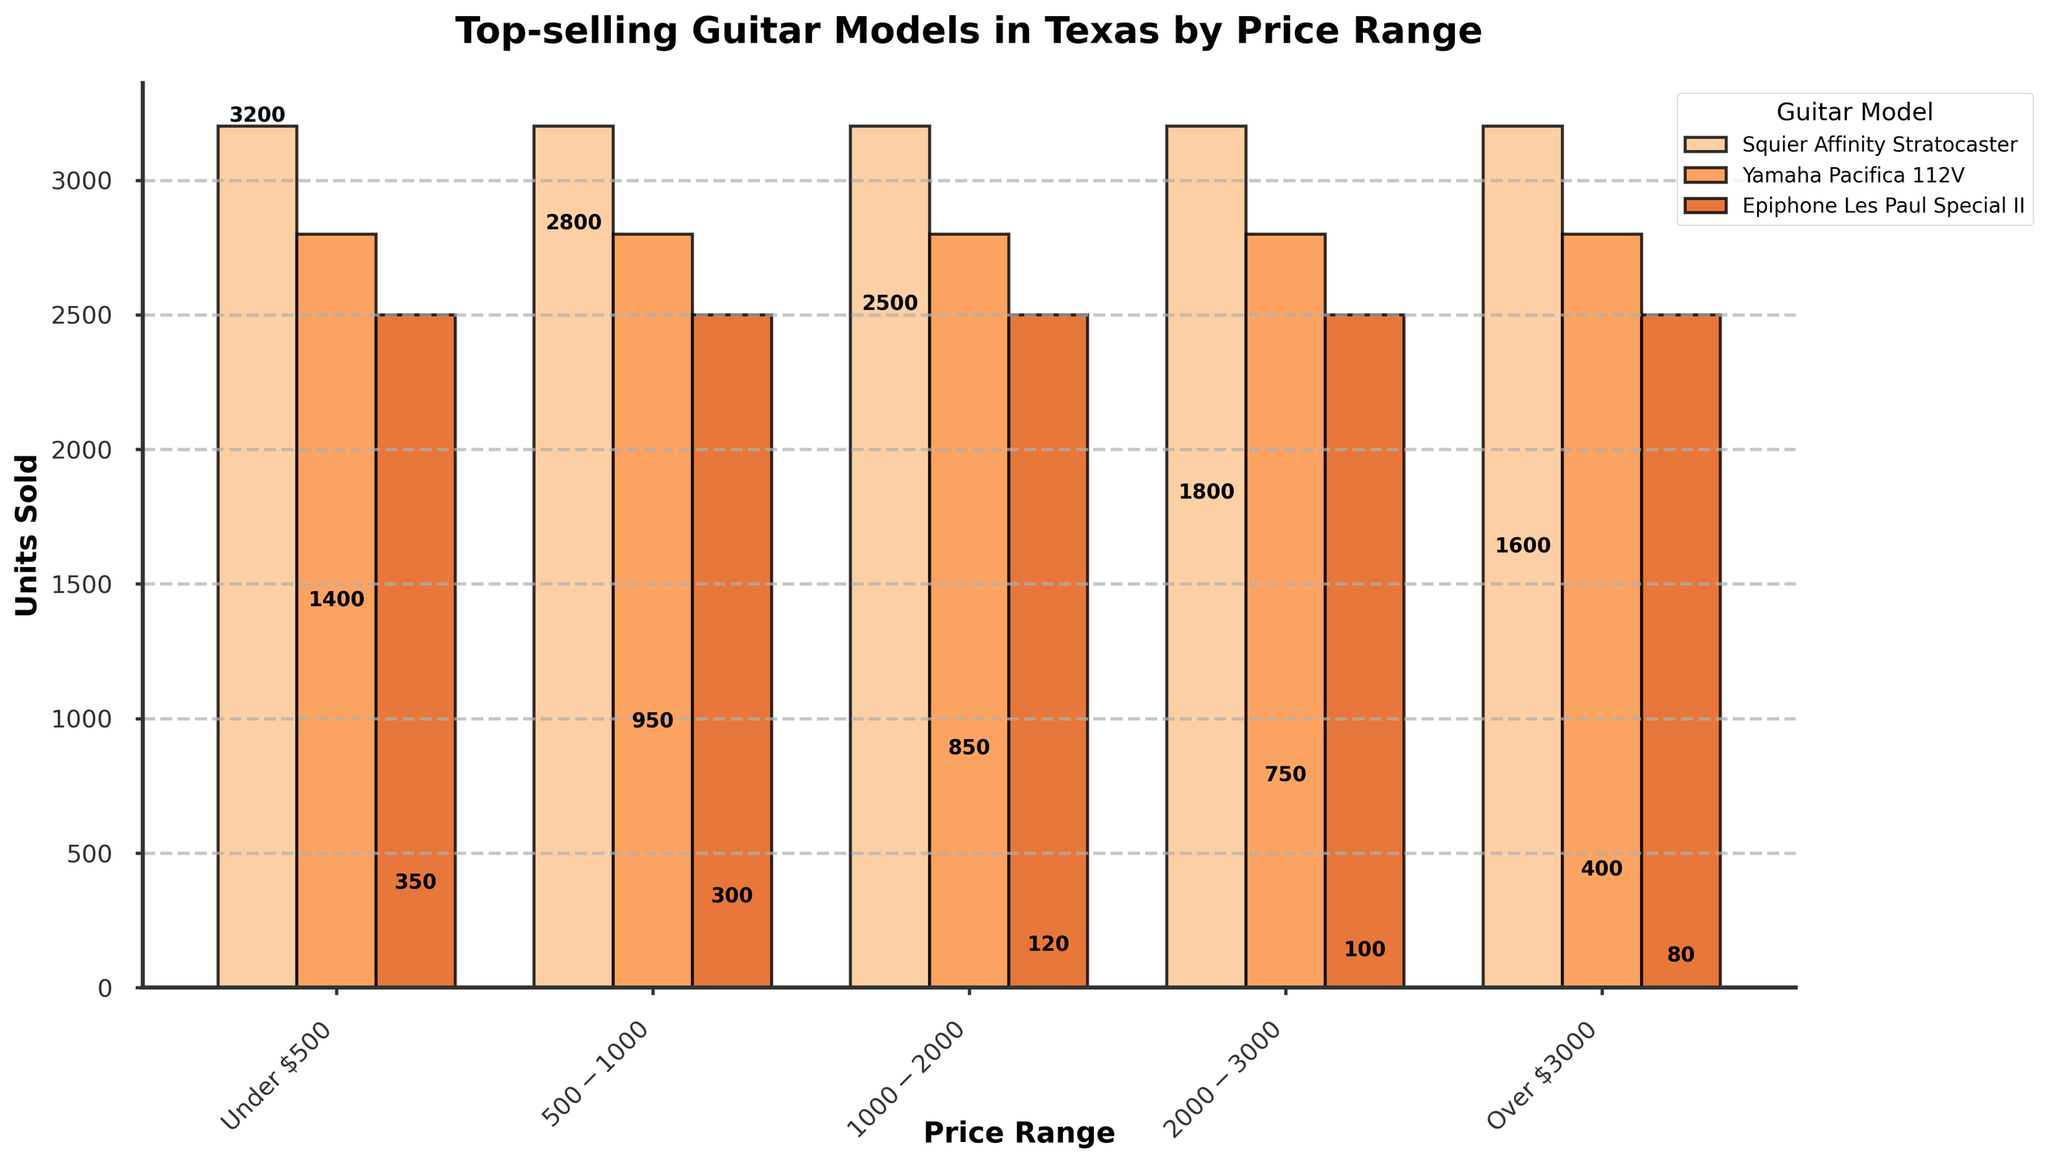What is the total number of units sold for guitar models in the price range Under $500? Add the units sold for Squier Affinity Stratocaster (3200), Yamaha Pacifica 112V (2800), and Epiphone Les Paul Special II (2500). 3200 + 2800 + 2500 = 8500.
Answer: 8500 Which guitar model in the $2000-$3000 price range sold the least number of units? Compare the units sold for Martin D-28 (400), Fender American Professional II Stratocaster (350), and Gibson SG Standard '61 (300). The Gibson SG Standard '61 has the least units sold.
Answer: Gibson SG Standard '61 Between the $500-$1000 and $1000-$2000 price ranges, which one has the higher total units sold? Sum the units sold for the $500-$1000 range (1800 + 1600 + 1400 = 4800) and the $1000-$2000 range (950 + 850 + 750 = 2550). Compare the totals: 4800 > 2550.
Answer: $500-$1000 What is the difference in units sold between the highest-selling guitar model and the lowest-selling guitar model? The highest-selling model is Squier Affinity Stratocaster (3200) and the lowest-selling model is Paul Reed Smith Custom 24 (80). Calculate 3200 - 80 = 3120.
Answer: 3120 Which guitar model among the Over $3000 price range has the second-highest units sold? Compare the units sold for Gibson Custom Shop 1959 Les Paul Standard Reissue (120), Fender Custom Shop 1960 Stratocaster Relic (100), and Paul Reed Smith Custom 24 (80). The second-highest is Fender Custom Shop 1960 Stratocaster Relic with 100 units.
Answer: Fender Custom Shop 1960 Stratocaster Relic How many more units did the Martin D-28 sell compared to the Fender American Professional II Stratocaster? The units sold for Martin D-28 is 400 and for Fender American Professional II Stratocaster is 350. Calculate 400 - 350 = 50.
Answer: 50 Which price range shows the greatest variability in units sold among its models? Assess visually by comparing the highest and lowest units sold within each price range. The $500-$1000 range (1800 to 1400), the $1000-$2000 range (950 to 750), the $2000-$3000 range (400 to 300), and the Over $3000 range (120 to 80). The price range Under $500 has the greatest variability (3200 to 2500).
Answer: Under $500 What is the average units sold for guitar models in the Over $3000 price range? Sum the units sold for Over $3000 models (120 + 100 + 80 = 300) and divide by the number of models (3). Calculate 300 / 3 = 100.
Answer: 100 